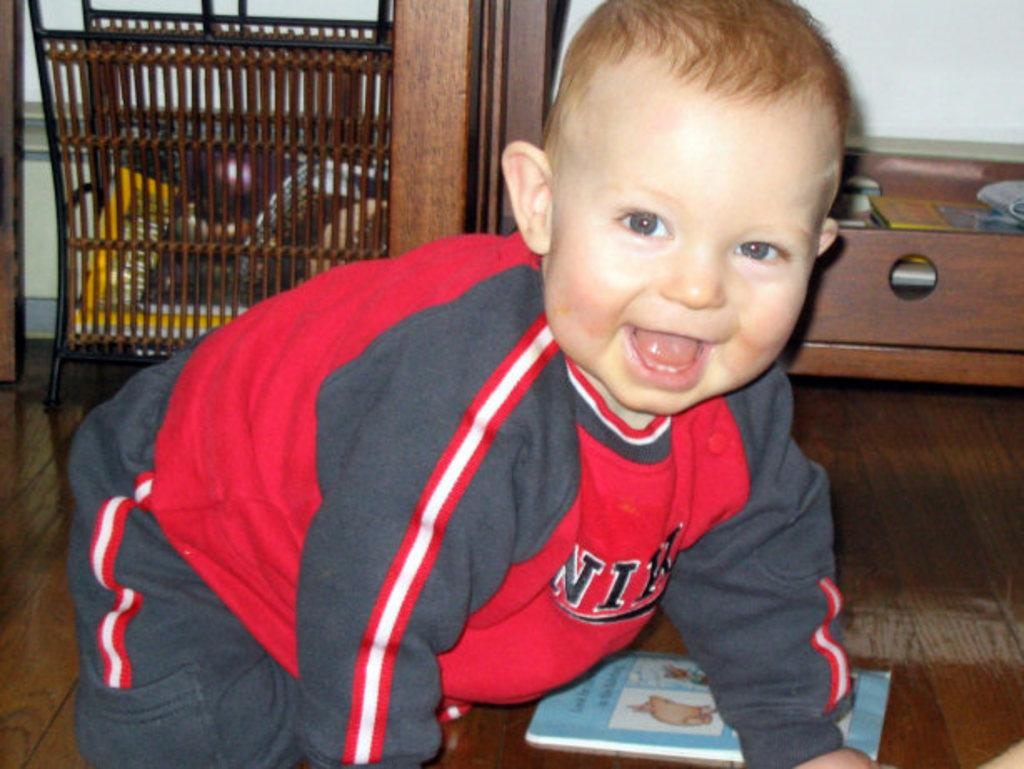<image>
Create a compact narrative representing the image presented. A small child wears a Nike sweatshirt and smiles. 